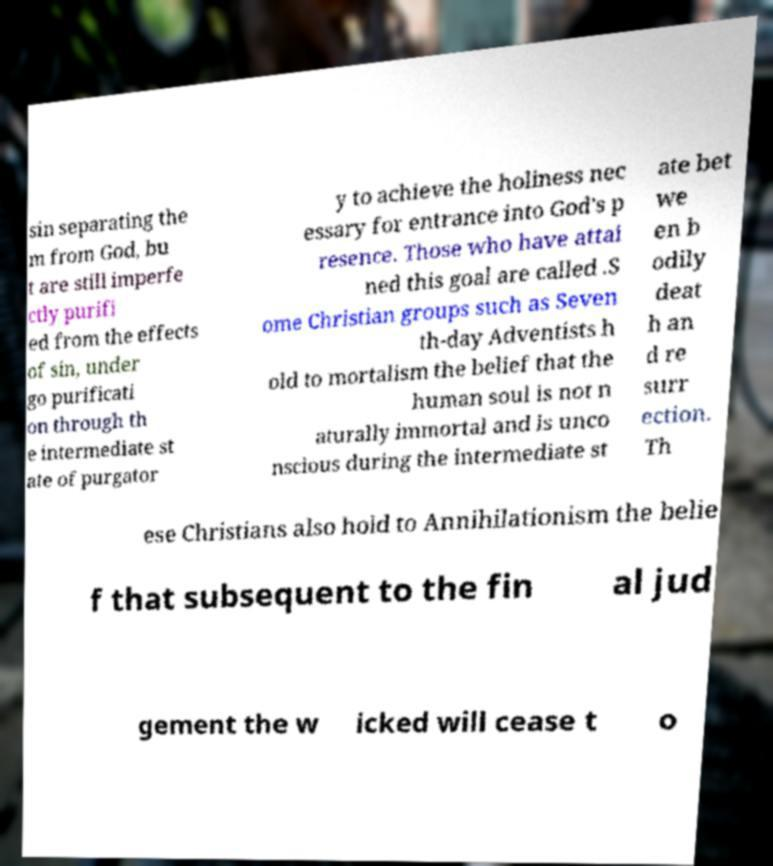I need the written content from this picture converted into text. Can you do that? sin separating the m from God, bu t are still imperfe ctly purifi ed from the effects of sin, under go purificati on through th e intermediate st ate of purgator y to achieve the holiness nec essary for entrance into God's p resence. Those who have attai ned this goal are called .S ome Christian groups such as Seven th-day Adventists h old to mortalism the belief that the human soul is not n aturally immortal and is unco nscious during the intermediate st ate bet we en b odily deat h an d re surr ection. Th ese Christians also hold to Annihilationism the belie f that subsequent to the fin al jud gement the w icked will cease t o 